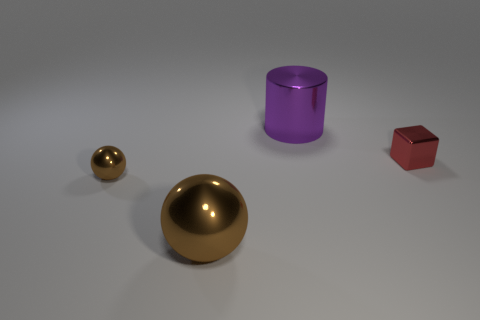What number of shiny things are there?
Your response must be concise. 4. What is the shape of the metal thing that is both behind the big brown object and to the left of the large purple shiny object?
Keep it short and to the point. Sphere. Is the color of the large thing that is to the left of the large purple cylinder the same as the tiny metallic object left of the purple thing?
Offer a very short reply. Yes. There is a object that is the same color as the big metal sphere; what size is it?
Offer a very short reply. Small. Are there any red cylinders that have the same material as the small brown sphere?
Your answer should be compact. No. Are there an equal number of metal objects behind the purple cylinder and metallic balls behind the big metal sphere?
Provide a succinct answer. No. How big is the brown sphere that is in front of the tiny brown ball?
Your response must be concise. Large. What number of brown metal things are behind the metallic thing in front of the small object that is on the left side of the red metal block?
Your response must be concise. 1. There is a tiny thing that is the same color as the big ball; what is it made of?
Your answer should be compact. Metal. What number of big brown metal things have the same shape as the small brown metal thing?
Give a very brief answer. 1. 